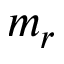<formula> <loc_0><loc_0><loc_500><loc_500>m _ { r }</formula> 